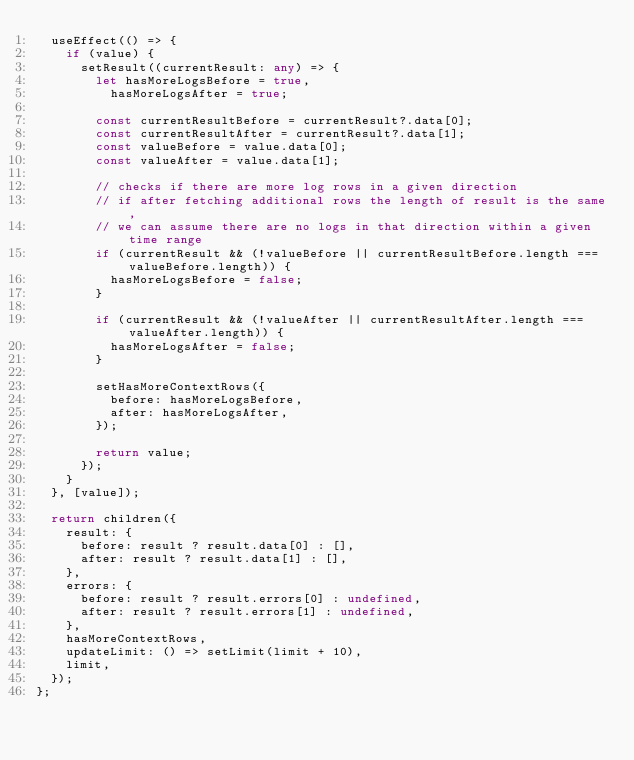Convert code to text. <code><loc_0><loc_0><loc_500><loc_500><_TypeScript_>  useEffect(() => {
    if (value) {
      setResult((currentResult: any) => {
        let hasMoreLogsBefore = true,
          hasMoreLogsAfter = true;

        const currentResultBefore = currentResult?.data[0];
        const currentResultAfter = currentResult?.data[1];
        const valueBefore = value.data[0];
        const valueAfter = value.data[1];

        // checks if there are more log rows in a given direction
        // if after fetching additional rows the length of result is the same,
        // we can assume there are no logs in that direction within a given time range
        if (currentResult && (!valueBefore || currentResultBefore.length === valueBefore.length)) {
          hasMoreLogsBefore = false;
        }

        if (currentResult && (!valueAfter || currentResultAfter.length === valueAfter.length)) {
          hasMoreLogsAfter = false;
        }

        setHasMoreContextRows({
          before: hasMoreLogsBefore,
          after: hasMoreLogsAfter,
        });

        return value;
      });
    }
  }, [value]);

  return children({
    result: {
      before: result ? result.data[0] : [],
      after: result ? result.data[1] : [],
    },
    errors: {
      before: result ? result.errors[0] : undefined,
      after: result ? result.errors[1] : undefined,
    },
    hasMoreContextRows,
    updateLimit: () => setLimit(limit + 10),
    limit,
  });
};
</code> 